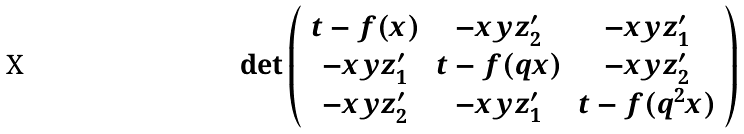Convert formula to latex. <formula><loc_0><loc_0><loc_500><loc_500>\det \left ( \begin{array} { c c c } t - f ( x ) & - x y z _ { 2 } ^ { \prime } & - x y z _ { 1 } ^ { \prime } \\ - x y z _ { 1 } ^ { \prime } & t - f ( q x ) & - x y z _ { 2 } ^ { \prime } \\ - x y z _ { 2 } ^ { \prime } & - x y z _ { 1 } ^ { \prime } & t - f ( q ^ { 2 } x ) \end{array} \right )</formula> 